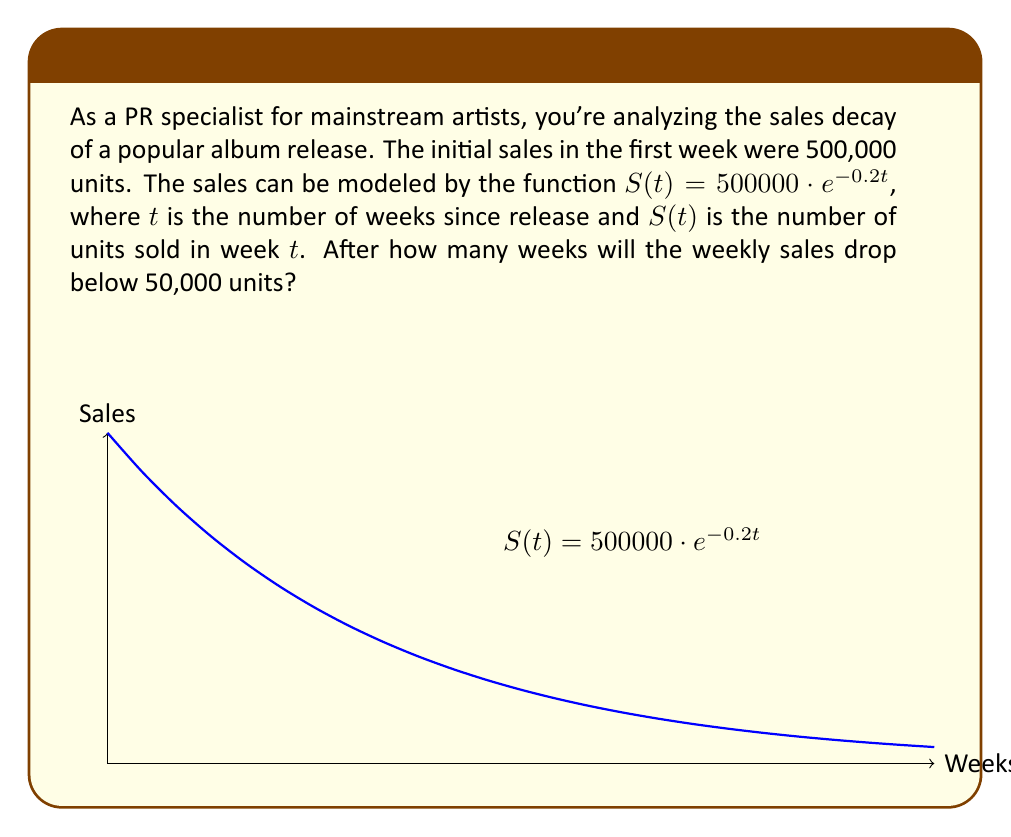Solve this math problem. To solve this problem, we need to find $t$ when $S(t) < 50000$:

1) Set up the inequality:
   $500000 \cdot e^{-0.2t} < 50000$

2) Divide both sides by 500000:
   $e^{-0.2t} < 0.1$

3) Take the natural log of both sides:
   $\ln(e^{-0.2t}) < \ln(0.1)$
   $-0.2t < \ln(0.1)$

4) Divide both sides by -0.2:
   $t > -\frac{\ln(0.1)}{0.2}$

5) Calculate the right side:
   $t > -\frac{-2.30259}{0.2} \approx 11.51295$

6) Since $t$ represents weeks, we need to round up to the next whole number:
   $t = 12$

Therefore, after 12 weeks, the weekly sales will drop below 50,000 units.
Answer: 12 weeks 